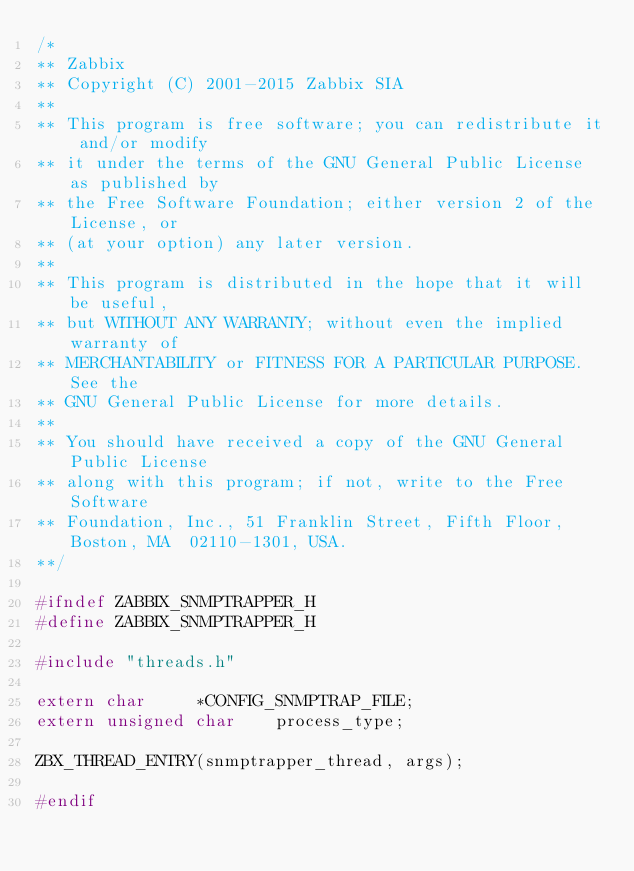<code> <loc_0><loc_0><loc_500><loc_500><_C_>/*
** Zabbix
** Copyright (C) 2001-2015 Zabbix SIA
**
** This program is free software; you can redistribute it and/or modify
** it under the terms of the GNU General Public License as published by
** the Free Software Foundation; either version 2 of the License, or
** (at your option) any later version.
**
** This program is distributed in the hope that it will be useful,
** but WITHOUT ANY WARRANTY; without even the implied warranty of
** MERCHANTABILITY or FITNESS FOR A PARTICULAR PURPOSE. See the
** GNU General Public License for more details.
**
** You should have received a copy of the GNU General Public License
** along with this program; if not, write to the Free Software
** Foundation, Inc., 51 Franklin Street, Fifth Floor, Boston, MA  02110-1301, USA.
**/

#ifndef ZABBIX_SNMPTRAPPER_H
#define ZABBIX_SNMPTRAPPER_H

#include "threads.h"

extern char		*CONFIG_SNMPTRAP_FILE;
extern unsigned char	process_type;

ZBX_THREAD_ENTRY(snmptrapper_thread, args);

#endif
</code> 